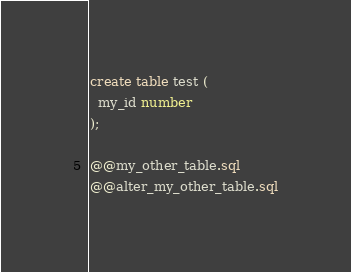<code> <loc_0><loc_0><loc_500><loc_500><_SQL_>create table test (
  my_id number
);

@@my_other_table.sql
@@alter_my_other_table.sql
</code> 